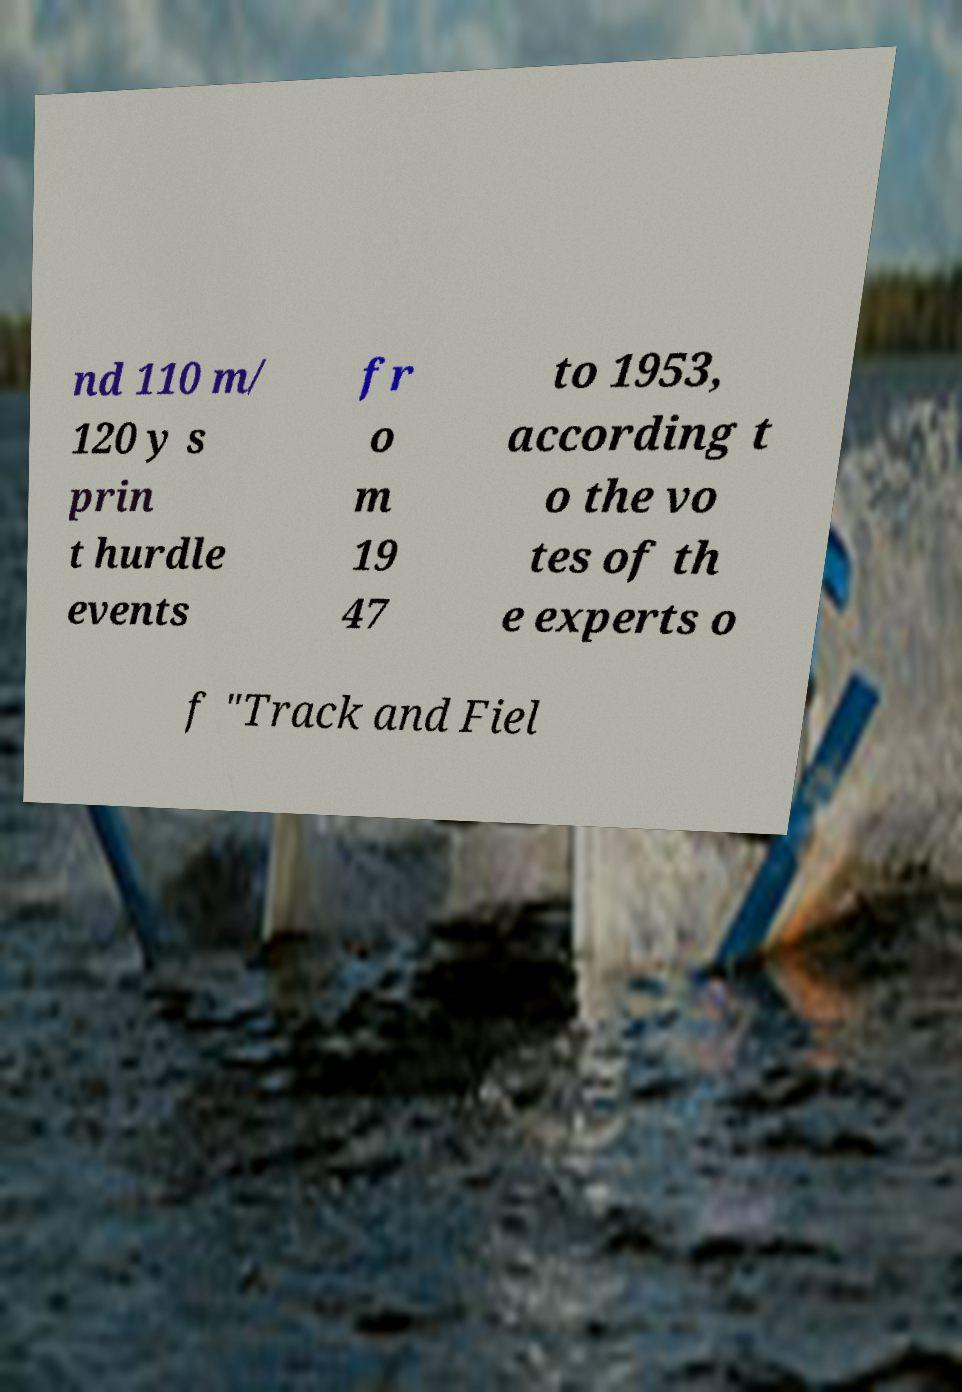For documentation purposes, I need the text within this image transcribed. Could you provide that? nd 110 m/ 120 y s prin t hurdle events fr o m 19 47 to 1953, according t o the vo tes of th e experts o f "Track and Fiel 